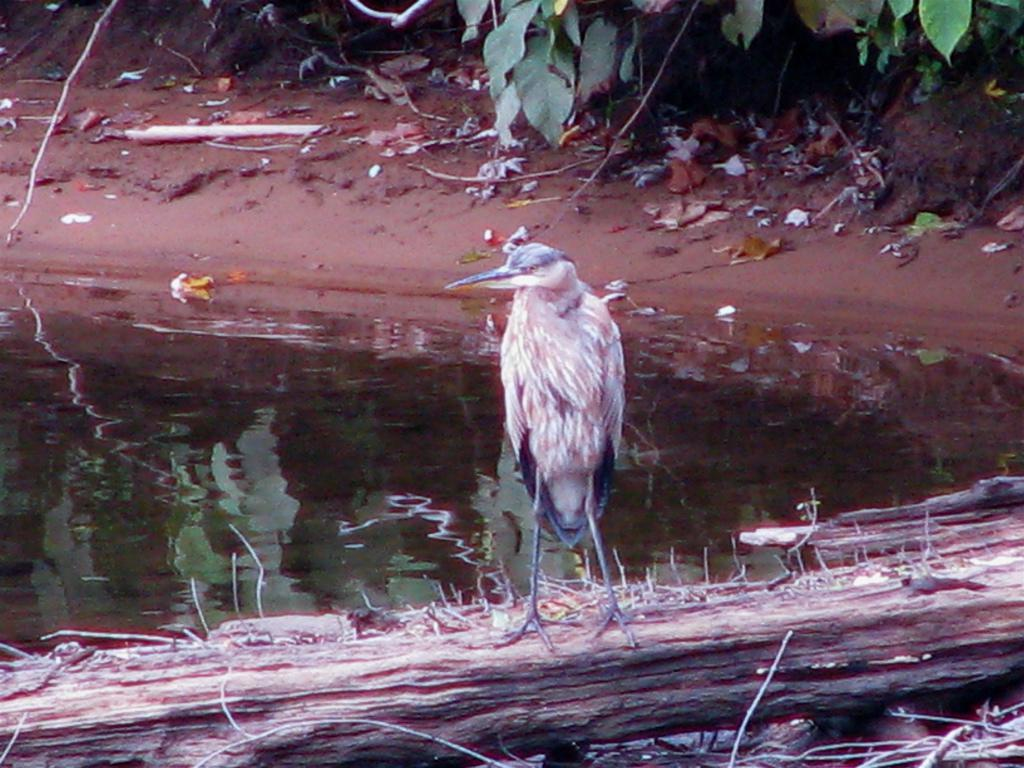What type of animal is in the image? There is a bird in the image. What is the bird standing on? The bird is standing on a piece of wood. Where is the wood located? The wood is in a pond. What can be seen on the shore of the pond? There are plants on the shore of the pond. How does the bird compare to the rake in the image? There is no rake present in the image, so it cannot be compared to the bird. 